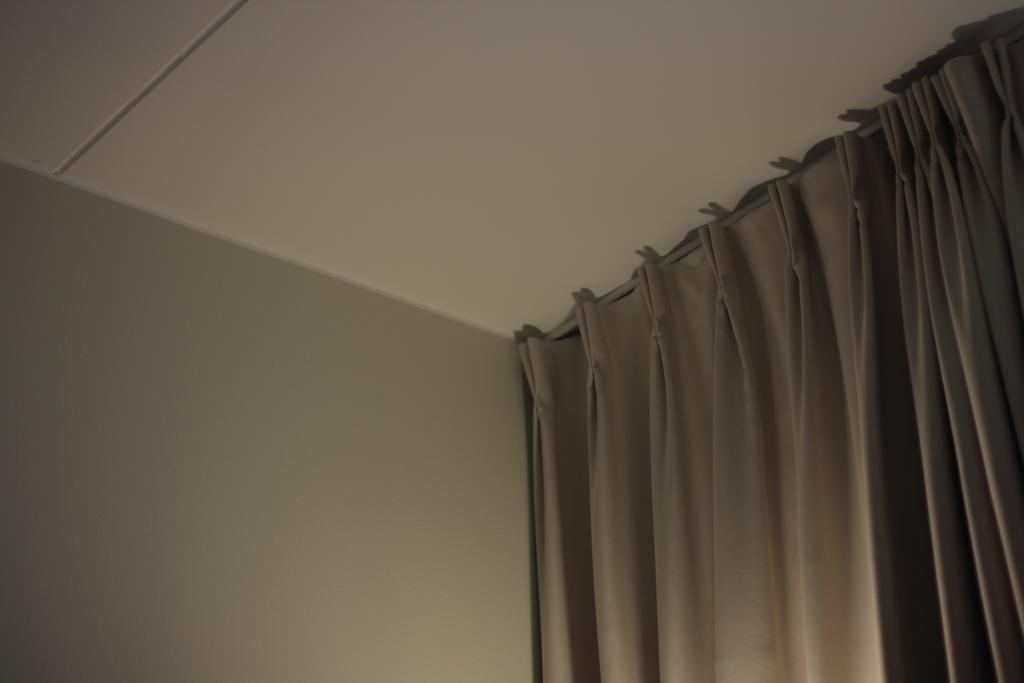Describe this image in one or two sentences. In this image, I can see the curtains hanging to the hanger. This is roof. I can see the wall. 